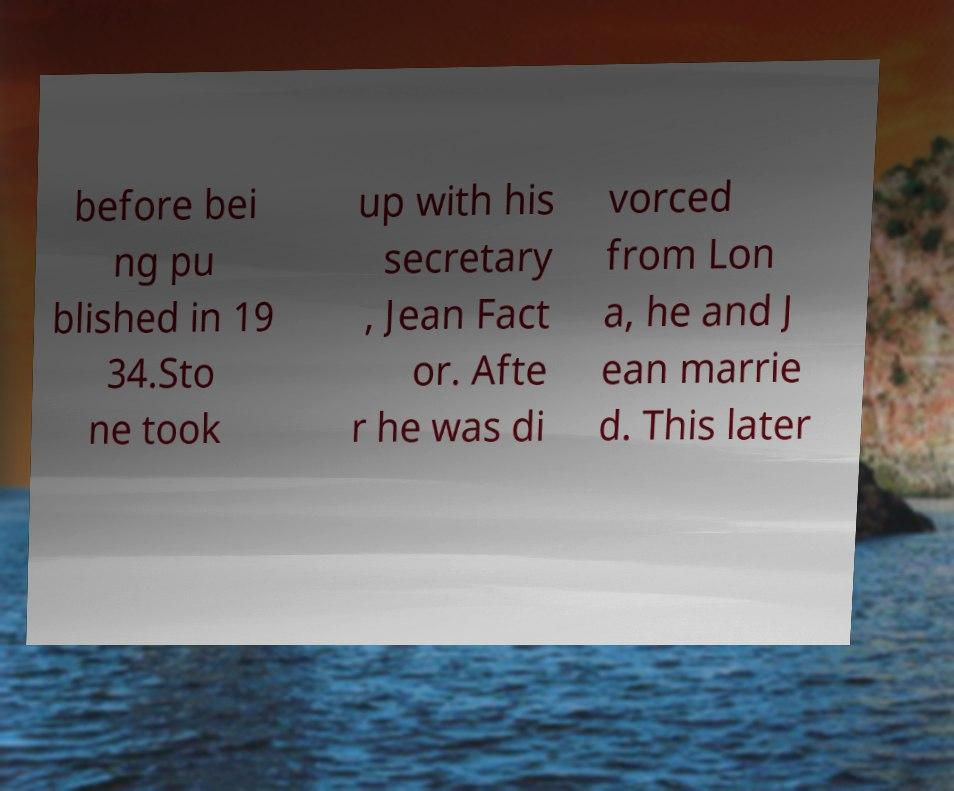For documentation purposes, I need the text within this image transcribed. Could you provide that? before bei ng pu blished in 19 34.Sto ne took up with his secretary , Jean Fact or. Afte r he was di vorced from Lon a, he and J ean marrie d. This later 